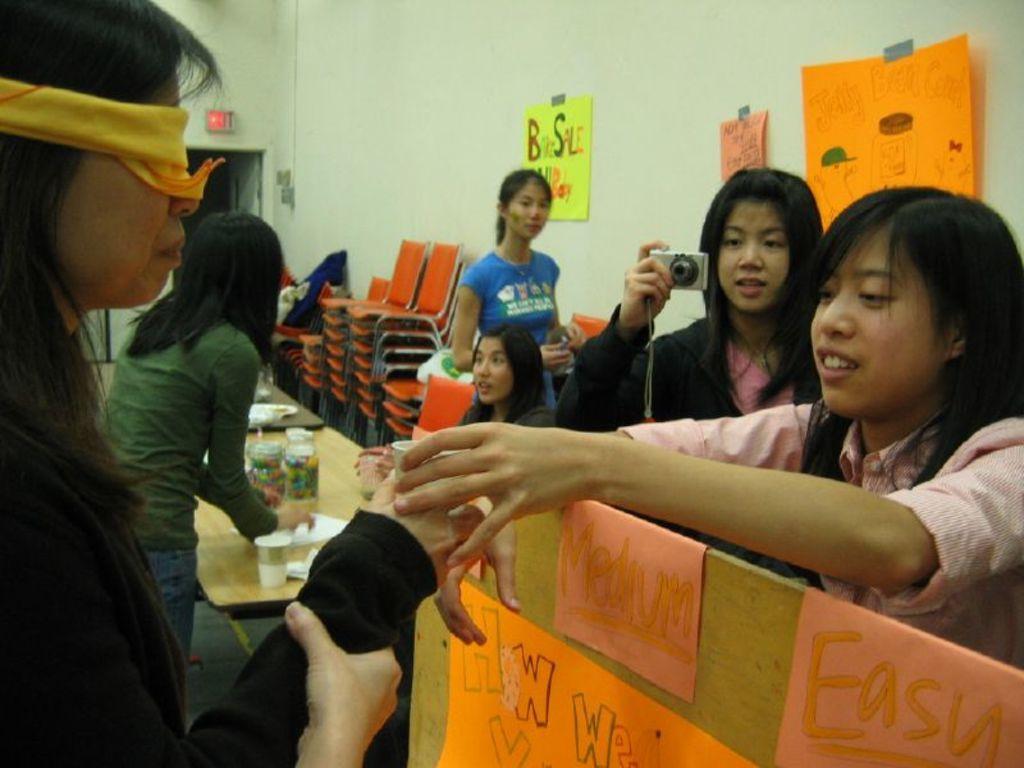How would you summarize this image in a sentence or two? In this image on the left side a woman is there, she wore black color dress and her eyes are tied with a yellow color kerchief. On the right side there is a woman touching this woman's hand, beside her a girl is shooting with a camera. In the middle there are chairs in orange color in this image. 